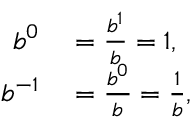<formula> <loc_0><loc_0><loc_500><loc_500>\begin{array} { r l } { b ^ { 0 } } & = { \frac { b ^ { 1 } } { b } } = 1 , } \\ { b ^ { - 1 } } & = { \frac { b ^ { 0 } } { b } } = { \frac { 1 } { b } } , } \end{array}</formula> 